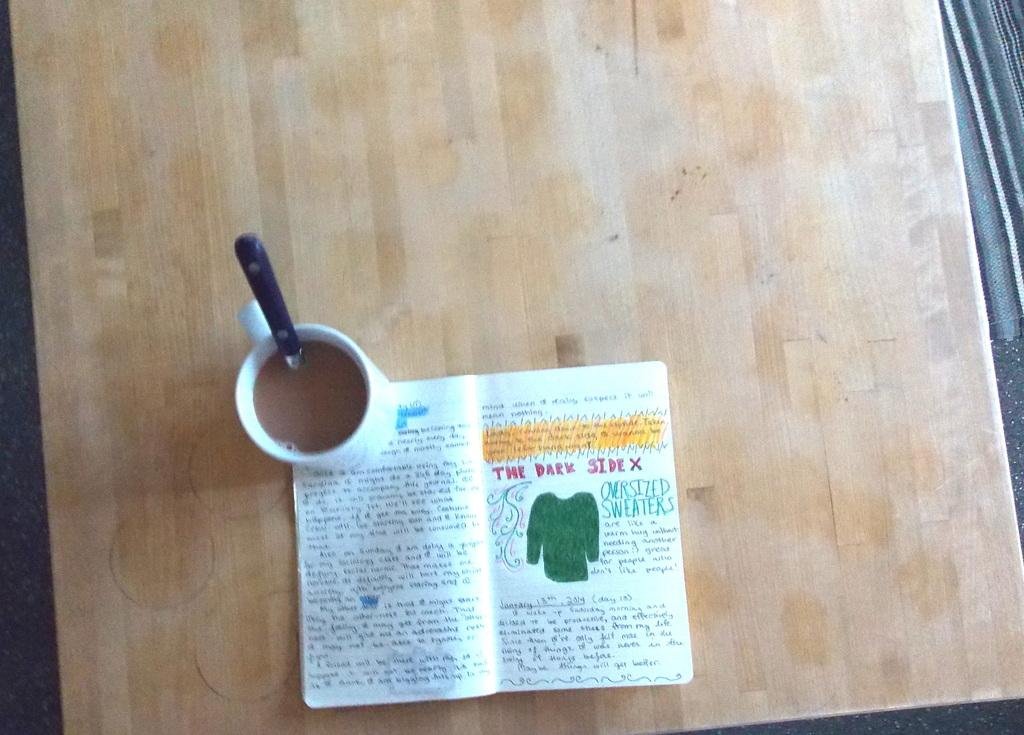<image>
Offer a succinct explanation of the picture presented. White Coffee mug sitting on the edge of a book that has red lettering the dark side X 